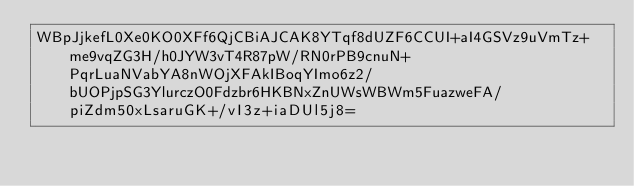<code> <loc_0><loc_0><loc_500><loc_500><_SML_>WBpJjkefL0Xe0KO0XFf6QjCBiAJCAK8YTqf8dUZF6CCUI+aI4GSVz9uVmTz+me9vqZG3H/h0JYW3vT4R87pW/RN0rPB9cnuN+PqrLuaNVabYA8nWOjXFAkIBoqYImo6z2/bUOPjpSG3YlurczO0Fdzbr6HKBNxZnUWsWBWm5FuazweFA/piZdm50xLsaruGK+/vI3z+iaDUl5j8=</code> 